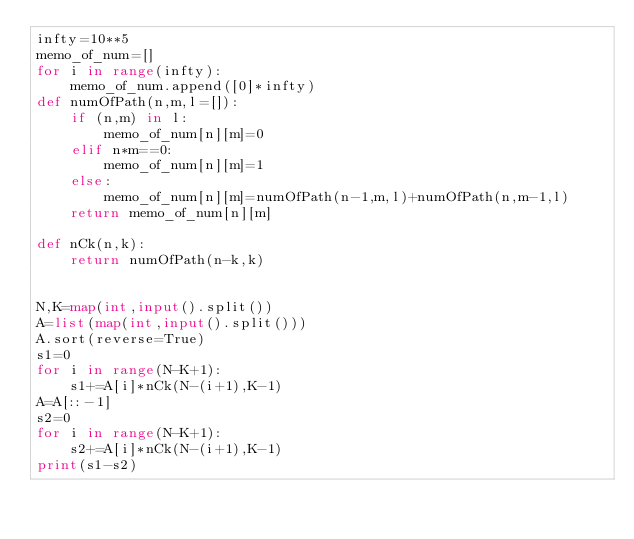<code> <loc_0><loc_0><loc_500><loc_500><_Python_>infty=10**5
memo_of_num=[]
for i in range(infty):
    memo_of_num.append([0]*infty)
def numOfPath(n,m,l=[]):
    if (n,m) in l:
        memo_of_num[n][m]=0
    elif n*m==0:
        memo_of_num[n][m]=1
    else:
        memo_of_num[n][m]=numOfPath(n-1,m,l)+numOfPath(n,m-1,l)
    return memo_of_num[n][m]

def nCk(n,k):
    return numOfPath(n-k,k)


N,K=map(int,input().split())
A=list(map(int,input().split()))
A.sort(reverse=True)
s1=0
for i in range(N-K+1):
    s1+=A[i]*nCk(N-(i+1),K-1)
A=A[::-1]
s2=0
for i in range(N-K+1):
    s2+=A[i]*nCk(N-(i+1),K-1)
print(s1-s2)</code> 